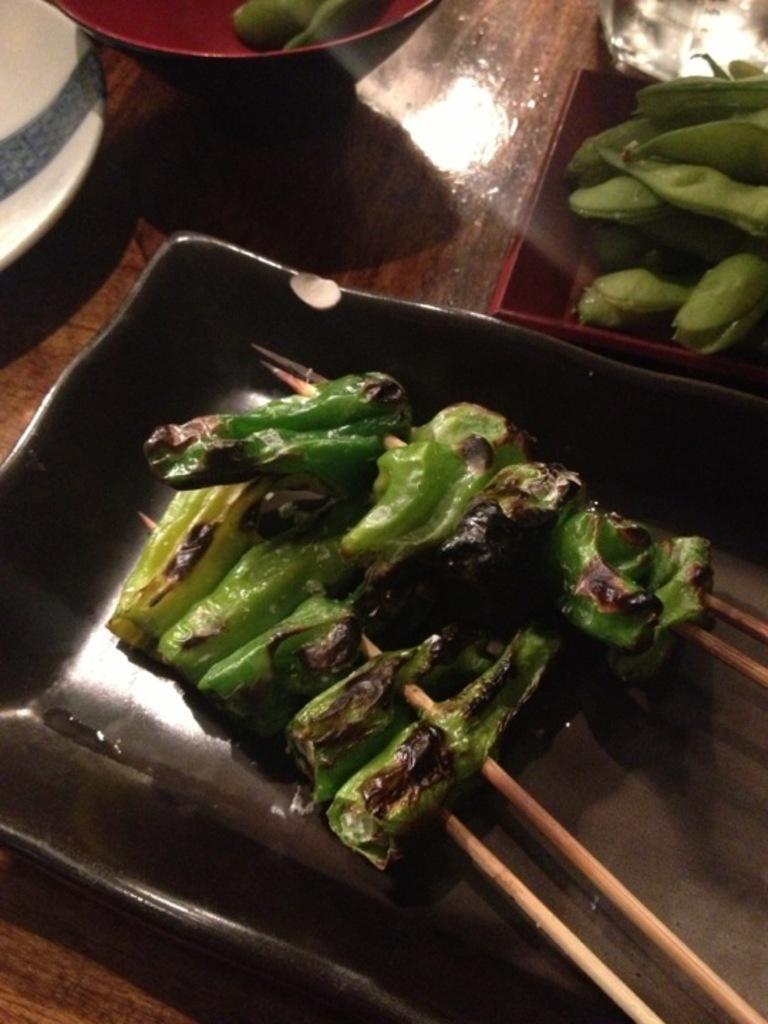Can you describe this image briefly? In this image, we can see some food items in containers are placed on the surface. We can also see a white colored object. We can see some wooden sticks. 